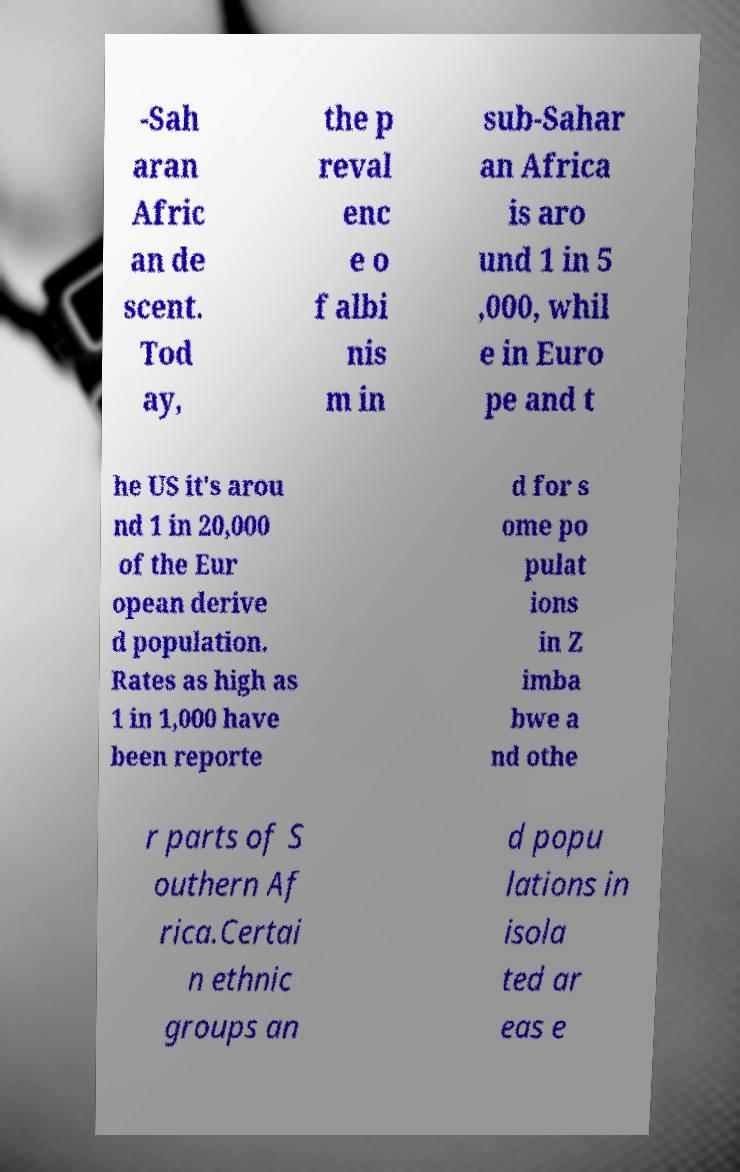For documentation purposes, I need the text within this image transcribed. Could you provide that? -Sah aran Afric an de scent. Tod ay, the p reval enc e o f albi nis m in sub-Sahar an Africa is aro und 1 in 5 ,000, whil e in Euro pe and t he US it's arou nd 1 in 20,000 of the Eur opean derive d population. Rates as high as 1 in 1,000 have been reporte d for s ome po pulat ions in Z imba bwe a nd othe r parts of S outhern Af rica.Certai n ethnic groups an d popu lations in isola ted ar eas e 